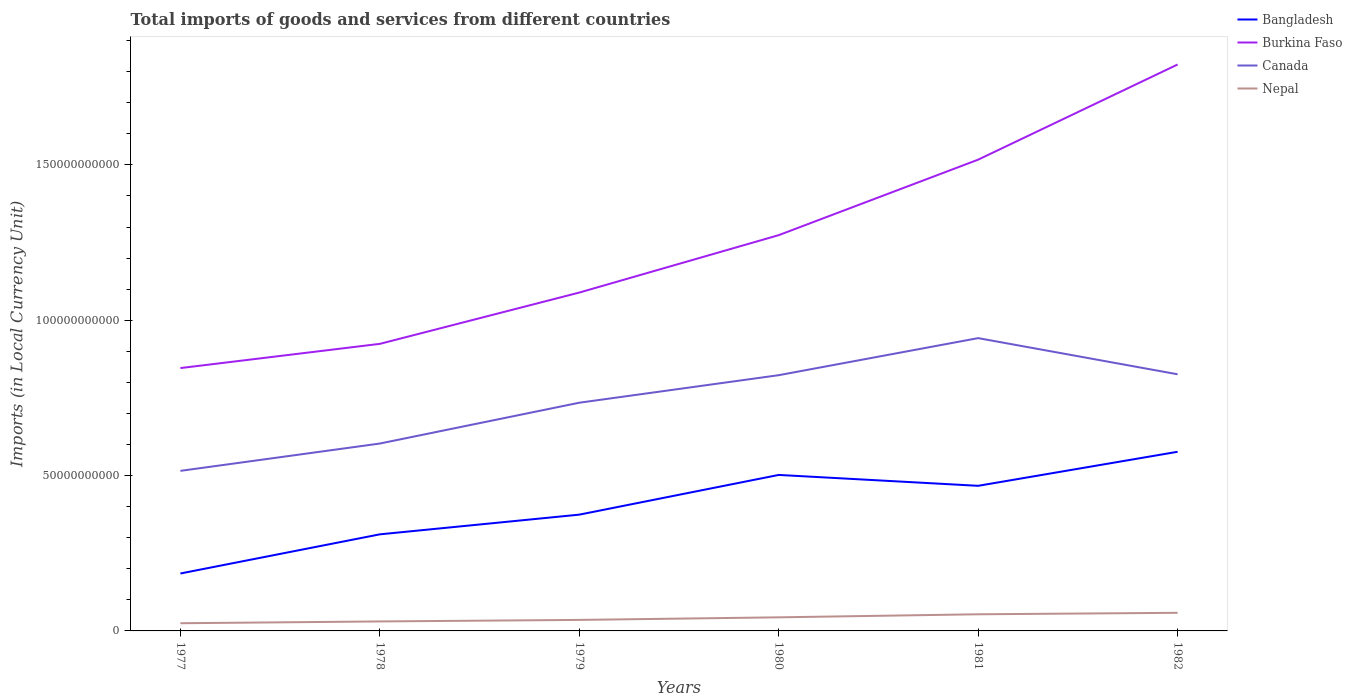How many different coloured lines are there?
Offer a very short reply. 4. Does the line corresponding to Burkina Faso intersect with the line corresponding to Bangladesh?
Provide a short and direct response. No. Is the number of lines equal to the number of legend labels?
Your response must be concise. Yes. Across all years, what is the maximum Amount of goods and services imports in Burkina Faso?
Provide a short and direct response. 8.46e+1. What is the total Amount of goods and services imports in Bangladesh in the graph?
Give a very brief answer. -1.10e+1. What is the difference between the highest and the second highest Amount of goods and services imports in Nepal?
Provide a short and direct response. 3.35e+09. What is the difference between the highest and the lowest Amount of goods and services imports in Burkina Faso?
Your answer should be compact. 3. Is the Amount of goods and services imports in Canada strictly greater than the Amount of goods and services imports in Bangladesh over the years?
Give a very brief answer. No. How many lines are there?
Give a very brief answer. 4. How many years are there in the graph?
Provide a succinct answer. 6. Are the values on the major ticks of Y-axis written in scientific E-notation?
Provide a succinct answer. No. Does the graph contain any zero values?
Your answer should be compact. No. Where does the legend appear in the graph?
Make the answer very short. Top right. How many legend labels are there?
Your answer should be compact. 4. What is the title of the graph?
Offer a very short reply. Total imports of goods and services from different countries. What is the label or title of the X-axis?
Provide a short and direct response. Years. What is the label or title of the Y-axis?
Provide a succinct answer. Imports (in Local Currency Unit). What is the Imports (in Local Currency Unit) of Bangladesh in 1977?
Offer a very short reply. 1.85e+1. What is the Imports (in Local Currency Unit) of Burkina Faso in 1977?
Give a very brief answer. 8.46e+1. What is the Imports (in Local Currency Unit) in Canada in 1977?
Your response must be concise. 5.15e+1. What is the Imports (in Local Currency Unit) of Nepal in 1977?
Your response must be concise. 2.47e+09. What is the Imports (in Local Currency Unit) in Bangladesh in 1978?
Keep it short and to the point. 3.11e+1. What is the Imports (in Local Currency Unit) of Burkina Faso in 1978?
Ensure brevity in your answer.  9.24e+1. What is the Imports (in Local Currency Unit) of Canada in 1978?
Provide a succinct answer. 6.03e+1. What is the Imports (in Local Currency Unit) of Nepal in 1978?
Keep it short and to the point. 3.05e+09. What is the Imports (in Local Currency Unit) of Bangladesh in 1979?
Your answer should be very brief. 3.74e+1. What is the Imports (in Local Currency Unit) of Burkina Faso in 1979?
Your answer should be very brief. 1.09e+11. What is the Imports (in Local Currency Unit) of Canada in 1979?
Provide a succinct answer. 7.35e+1. What is the Imports (in Local Currency Unit) of Nepal in 1979?
Your response must be concise. 3.55e+09. What is the Imports (in Local Currency Unit) in Bangladesh in 1980?
Give a very brief answer. 5.02e+1. What is the Imports (in Local Currency Unit) in Burkina Faso in 1980?
Offer a terse response. 1.27e+11. What is the Imports (in Local Currency Unit) of Canada in 1980?
Offer a very short reply. 8.23e+1. What is the Imports (in Local Currency Unit) of Nepal in 1980?
Your answer should be compact. 4.37e+09. What is the Imports (in Local Currency Unit) of Bangladesh in 1981?
Ensure brevity in your answer.  4.67e+1. What is the Imports (in Local Currency Unit) in Burkina Faso in 1981?
Make the answer very short. 1.52e+11. What is the Imports (in Local Currency Unit) in Canada in 1981?
Your answer should be compact. 9.42e+1. What is the Imports (in Local Currency Unit) in Nepal in 1981?
Keep it short and to the point. 5.36e+09. What is the Imports (in Local Currency Unit) of Bangladesh in 1982?
Make the answer very short. 5.77e+1. What is the Imports (in Local Currency Unit) of Burkina Faso in 1982?
Your response must be concise. 1.82e+11. What is the Imports (in Local Currency Unit) of Canada in 1982?
Make the answer very short. 8.26e+1. What is the Imports (in Local Currency Unit) in Nepal in 1982?
Make the answer very short. 5.83e+09. Across all years, what is the maximum Imports (in Local Currency Unit) of Bangladesh?
Offer a terse response. 5.77e+1. Across all years, what is the maximum Imports (in Local Currency Unit) in Burkina Faso?
Provide a succinct answer. 1.82e+11. Across all years, what is the maximum Imports (in Local Currency Unit) in Canada?
Offer a very short reply. 9.42e+1. Across all years, what is the maximum Imports (in Local Currency Unit) of Nepal?
Your answer should be very brief. 5.83e+09. Across all years, what is the minimum Imports (in Local Currency Unit) in Bangladesh?
Provide a short and direct response. 1.85e+1. Across all years, what is the minimum Imports (in Local Currency Unit) in Burkina Faso?
Ensure brevity in your answer.  8.46e+1. Across all years, what is the minimum Imports (in Local Currency Unit) in Canada?
Your answer should be compact. 5.15e+1. Across all years, what is the minimum Imports (in Local Currency Unit) of Nepal?
Provide a succinct answer. 2.47e+09. What is the total Imports (in Local Currency Unit) of Bangladesh in the graph?
Provide a succinct answer. 2.42e+11. What is the total Imports (in Local Currency Unit) in Burkina Faso in the graph?
Provide a succinct answer. 7.47e+11. What is the total Imports (in Local Currency Unit) in Canada in the graph?
Keep it short and to the point. 4.44e+11. What is the total Imports (in Local Currency Unit) in Nepal in the graph?
Your answer should be very brief. 2.46e+1. What is the difference between the Imports (in Local Currency Unit) in Bangladesh in 1977 and that in 1978?
Ensure brevity in your answer.  -1.26e+1. What is the difference between the Imports (in Local Currency Unit) in Burkina Faso in 1977 and that in 1978?
Offer a terse response. -7.80e+09. What is the difference between the Imports (in Local Currency Unit) of Canada in 1977 and that in 1978?
Your response must be concise. -8.80e+09. What is the difference between the Imports (in Local Currency Unit) in Nepal in 1977 and that in 1978?
Your answer should be compact. -5.79e+08. What is the difference between the Imports (in Local Currency Unit) of Bangladesh in 1977 and that in 1979?
Your response must be concise. -1.89e+1. What is the difference between the Imports (in Local Currency Unit) of Burkina Faso in 1977 and that in 1979?
Keep it short and to the point. -2.43e+1. What is the difference between the Imports (in Local Currency Unit) in Canada in 1977 and that in 1979?
Keep it short and to the point. -2.19e+1. What is the difference between the Imports (in Local Currency Unit) in Nepal in 1977 and that in 1979?
Ensure brevity in your answer.  -1.07e+09. What is the difference between the Imports (in Local Currency Unit) of Bangladesh in 1977 and that in 1980?
Make the answer very short. -3.17e+1. What is the difference between the Imports (in Local Currency Unit) of Burkina Faso in 1977 and that in 1980?
Ensure brevity in your answer.  -4.28e+1. What is the difference between the Imports (in Local Currency Unit) in Canada in 1977 and that in 1980?
Keep it short and to the point. -3.08e+1. What is the difference between the Imports (in Local Currency Unit) in Nepal in 1977 and that in 1980?
Ensure brevity in your answer.  -1.90e+09. What is the difference between the Imports (in Local Currency Unit) of Bangladesh in 1977 and that in 1981?
Your answer should be very brief. -2.82e+1. What is the difference between the Imports (in Local Currency Unit) in Burkina Faso in 1977 and that in 1981?
Offer a very short reply. -6.71e+1. What is the difference between the Imports (in Local Currency Unit) of Canada in 1977 and that in 1981?
Keep it short and to the point. -4.27e+1. What is the difference between the Imports (in Local Currency Unit) of Nepal in 1977 and that in 1981?
Ensure brevity in your answer.  -2.88e+09. What is the difference between the Imports (in Local Currency Unit) of Bangladesh in 1977 and that in 1982?
Offer a very short reply. -3.92e+1. What is the difference between the Imports (in Local Currency Unit) of Burkina Faso in 1977 and that in 1982?
Provide a short and direct response. -9.77e+1. What is the difference between the Imports (in Local Currency Unit) in Canada in 1977 and that in 1982?
Provide a short and direct response. -3.11e+1. What is the difference between the Imports (in Local Currency Unit) of Nepal in 1977 and that in 1982?
Give a very brief answer. -3.35e+09. What is the difference between the Imports (in Local Currency Unit) in Bangladesh in 1978 and that in 1979?
Your answer should be compact. -6.34e+09. What is the difference between the Imports (in Local Currency Unit) of Burkina Faso in 1978 and that in 1979?
Give a very brief answer. -1.65e+1. What is the difference between the Imports (in Local Currency Unit) in Canada in 1978 and that in 1979?
Your answer should be compact. -1.31e+1. What is the difference between the Imports (in Local Currency Unit) in Nepal in 1978 and that in 1979?
Make the answer very short. -4.94e+08. What is the difference between the Imports (in Local Currency Unit) in Bangladesh in 1978 and that in 1980?
Make the answer very short. -1.91e+1. What is the difference between the Imports (in Local Currency Unit) of Burkina Faso in 1978 and that in 1980?
Your response must be concise. -3.50e+1. What is the difference between the Imports (in Local Currency Unit) of Canada in 1978 and that in 1980?
Your answer should be compact. -2.20e+1. What is the difference between the Imports (in Local Currency Unit) in Nepal in 1978 and that in 1980?
Make the answer very short. -1.32e+09. What is the difference between the Imports (in Local Currency Unit) of Bangladesh in 1978 and that in 1981?
Provide a short and direct response. -1.56e+1. What is the difference between the Imports (in Local Currency Unit) in Burkina Faso in 1978 and that in 1981?
Provide a short and direct response. -5.93e+1. What is the difference between the Imports (in Local Currency Unit) of Canada in 1978 and that in 1981?
Your answer should be compact. -3.39e+1. What is the difference between the Imports (in Local Currency Unit) in Nepal in 1978 and that in 1981?
Keep it short and to the point. -2.30e+09. What is the difference between the Imports (in Local Currency Unit) in Bangladesh in 1978 and that in 1982?
Keep it short and to the point. -2.66e+1. What is the difference between the Imports (in Local Currency Unit) of Burkina Faso in 1978 and that in 1982?
Give a very brief answer. -8.99e+1. What is the difference between the Imports (in Local Currency Unit) of Canada in 1978 and that in 1982?
Give a very brief answer. -2.23e+1. What is the difference between the Imports (in Local Currency Unit) of Nepal in 1978 and that in 1982?
Make the answer very short. -2.77e+09. What is the difference between the Imports (in Local Currency Unit) of Bangladesh in 1979 and that in 1980?
Provide a short and direct response. -1.28e+1. What is the difference between the Imports (in Local Currency Unit) in Burkina Faso in 1979 and that in 1980?
Provide a succinct answer. -1.85e+1. What is the difference between the Imports (in Local Currency Unit) of Canada in 1979 and that in 1980?
Make the answer very short. -8.86e+09. What is the difference between the Imports (in Local Currency Unit) of Nepal in 1979 and that in 1980?
Give a very brief answer. -8.27e+08. What is the difference between the Imports (in Local Currency Unit) in Bangladesh in 1979 and that in 1981?
Your response must be concise. -9.28e+09. What is the difference between the Imports (in Local Currency Unit) in Burkina Faso in 1979 and that in 1981?
Keep it short and to the point. -4.28e+1. What is the difference between the Imports (in Local Currency Unit) in Canada in 1979 and that in 1981?
Your response must be concise. -2.08e+1. What is the difference between the Imports (in Local Currency Unit) of Nepal in 1979 and that in 1981?
Keep it short and to the point. -1.81e+09. What is the difference between the Imports (in Local Currency Unit) of Bangladesh in 1979 and that in 1982?
Make the answer very short. -2.02e+1. What is the difference between the Imports (in Local Currency Unit) in Burkina Faso in 1979 and that in 1982?
Offer a terse response. -7.34e+1. What is the difference between the Imports (in Local Currency Unit) in Canada in 1979 and that in 1982?
Your response must be concise. -9.15e+09. What is the difference between the Imports (in Local Currency Unit) in Nepal in 1979 and that in 1982?
Provide a short and direct response. -2.28e+09. What is the difference between the Imports (in Local Currency Unit) in Bangladesh in 1980 and that in 1981?
Ensure brevity in your answer.  3.50e+09. What is the difference between the Imports (in Local Currency Unit) in Burkina Faso in 1980 and that in 1981?
Ensure brevity in your answer.  -2.43e+1. What is the difference between the Imports (in Local Currency Unit) in Canada in 1980 and that in 1981?
Give a very brief answer. -1.19e+1. What is the difference between the Imports (in Local Currency Unit) of Nepal in 1980 and that in 1981?
Make the answer very short. -9.83e+08. What is the difference between the Imports (in Local Currency Unit) in Bangladesh in 1980 and that in 1982?
Make the answer very short. -7.45e+09. What is the difference between the Imports (in Local Currency Unit) in Burkina Faso in 1980 and that in 1982?
Ensure brevity in your answer.  -5.49e+1. What is the difference between the Imports (in Local Currency Unit) in Canada in 1980 and that in 1982?
Your response must be concise. -2.93e+08. What is the difference between the Imports (in Local Currency Unit) in Nepal in 1980 and that in 1982?
Your response must be concise. -1.45e+09. What is the difference between the Imports (in Local Currency Unit) of Bangladesh in 1981 and that in 1982?
Provide a short and direct response. -1.10e+1. What is the difference between the Imports (in Local Currency Unit) in Burkina Faso in 1981 and that in 1982?
Keep it short and to the point. -3.06e+1. What is the difference between the Imports (in Local Currency Unit) of Canada in 1981 and that in 1982?
Your response must be concise. 1.16e+1. What is the difference between the Imports (in Local Currency Unit) in Nepal in 1981 and that in 1982?
Ensure brevity in your answer.  -4.71e+08. What is the difference between the Imports (in Local Currency Unit) in Bangladesh in 1977 and the Imports (in Local Currency Unit) in Burkina Faso in 1978?
Give a very brief answer. -7.39e+1. What is the difference between the Imports (in Local Currency Unit) of Bangladesh in 1977 and the Imports (in Local Currency Unit) of Canada in 1978?
Offer a terse response. -4.18e+1. What is the difference between the Imports (in Local Currency Unit) in Bangladesh in 1977 and the Imports (in Local Currency Unit) in Nepal in 1978?
Offer a very short reply. 1.54e+1. What is the difference between the Imports (in Local Currency Unit) of Burkina Faso in 1977 and the Imports (in Local Currency Unit) of Canada in 1978?
Keep it short and to the point. 2.43e+1. What is the difference between the Imports (in Local Currency Unit) in Burkina Faso in 1977 and the Imports (in Local Currency Unit) in Nepal in 1978?
Your answer should be very brief. 8.16e+1. What is the difference between the Imports (in Local Currency Unit) of Canada in 1977 and the Imports (in Local Currency Unit) of Nepal in 1978?
Your response must be concise. 4.85e+1. What is the difference between the Imports (in Local Currency Unit) in Bangladesh in 1977 and the Imports (in Local Currency Unit) in Burkina Faso in 1979?
Provide a short and direct response. -9.04e+1. What is the difference between the Imports (in Local Currency Unit) in Bangladesh in 1977 and the Imports (in Local Currency Unit) in Canada in 1979?
Your answer should be compact. -5.50e+1. What is the difference between the Imports (in Local Currency Unit) of Bangladesh in 1977 and the Imports (in Local Currency Unit) of Nepal in 1979?
Ensure brevity in your answer.  1.49e+1. What is the difference between the Imports (in Local Currency Unit) in Burkina Faso in 1977 and the Imports (in Local Currency Unit) in Canada in 1979?
Provide a succinct answer. 1.12e+1. What is the difference between the Imports (in Local Currency Unit) in Burkina Faso in 1977 and the Imports (in Local Currency Unit) in Nepal in 1979?
Provide a succinct answer. 8.11e+1. What is the difference between the Imports (in Local Currency Unit) of Canada in 1977 and the Imports (in Local Currency Unit) of Nepal in 1979?
Offer a very short reply. 4.80e+1. What is the difference between the Imports (in Local Currency Unit) in Bangladesh in 1977 and the Imports (in Local Currency Unit) in Burkina Faso in 1980?
Provide a succinct answer. -1.09e+11. What is the difference between the Imports (in Local Currency Unit) in Bangladesh in 1977 and the Imports (in Local Currency Unit) in Canada in 1980?
Provide a succinct answer. -6.38e+1. What is the difference between the Imports (in Local Currency Unit) in Bangladesh in 1977 and the Imports (in Local Currency Unit) in Nepal in 1980?
Keep it short and to the point. 1.41e+1. What is the difference between the Imports (in Local Currency Unit) in Burkina Faso in 1977 and the Imports (in Local Currency Unit) in Canada in 1980?
Offer a terse response. 2.29e+09. What is the difference between the Imports (in Local Currency Unit) of Burkina Faso in 1977 and the Imports (in Local Currency Unit) of Nepal in 1980?
Your response must be concise. 8.02e+1. What is the difference between the Imports (in Local Currency Unit) of Canada in 1977 and the Imports (in Local Currency Unit) of Nepal in 1980?
Give a very brief answer. 4.71e+1. What is the difference between the Imports (in Local Currency Unit) of Bangladesh in 1977 and the Imports (in Local Currency Unit) of Burkina Faso in 1981?
Provide a succinct answer. -1.33e+11. What is the difference between the Imports (in Local Currency Unit) in Bangladesh in 1977 and the Imports (in Local Currency Unit) in Canada in 1981?
Provide a succinct answer. -7.58e+1. What is the difference between the Imports (in Local Currency Unit) of Bangladesh in 1977 and the Imports (in Local Currency Unit) of Nepal in 1981?
Keep it short and to the point. 1.31e+1. What is the difference between the Imports (in Local Currency Unit) of Burkina Faso in 1977 and the Imports (in Local Currency Unit) of Canada in 1981?
Give a very brief answer. -9.64e+09. What is the difference between the Imports (in Local Currency Unit) of Burkina Faso in 1977 and the Imports (in Local Currency Unit) of Nepal in 1981?
Offer a very short reply. 7.93e+1. What is the difference between the Imports (in Local Currency Unit) of Canada in 1977 and the Imports (in Local Currency Unit) of Nepal in 1981?
Your answer should be compact. 4.62e+1. What is the difference between the Imports (in Local Currency Unit) of Bangladesh in 1977 and the Imports (in Local Currency Unit) of Burkina Faso in 1982?
Offer a terse response. -1.64e+11. What is the difference between the Imports (in Local Currency Unit) in Bangladesh in 1977 and the Imports (in Local Currency Unit) in Canada in 1982?
Your response must be concise. -6.41e+1. What is the difference between the Imports (in Local Currency Unit) of Bangladesh in 1977 and the Imports (in Local Currency Unit) of Nepal in 1982?
Provide a short and direct response. 1.27e+1. What is the difference between the Imports (in Local Currency Unit) in Burkina Faso in 1977 and the Imports (in Local Currency Unit) in Canada in 1982?
Keep it short and to the point. 2.00e+09. What is the difference between the Imports (in Local Currency Unit) in Burkina Faso in 1977 and the Imports (in Local Currency Unit) in Nepal in 1982?
Offer a terse response. 7.88e+1. What is the difference between the Imports (in Local Currency Unit) of Canada in 1977 and the Imports (in Local Currency Unit) of Nepal in 1982?
Make the answer very short. 4.57e+1. What is the difference between the Imports (in Local Currency Unit) in Bangladesh in 1978 and the Imports (in Local Currency Unit) in Burkina Faso in 1979?
Ensure brevity in your answer.  -7.78e+1. What is the difference between the Imports (in Local Currency Unit) in Bangladesh in 1978 and the Imports (in Local Currency Unit) in Canada in 1979?
Provide a short and direct response. -4.24e+1. What is the difference between the Imports (in Local Currency Unit) of Bangladesh in 1978 and the Imports (in Local Currency Unit) of Nepal in 1979?
Provide a succinct answer. 2.75e+1. What is the difference between the Imports (in Local Currency Unit) in Burkina Faso in 1978 and the Imports (in Local Currency Unit) in Canada in 1979?
Your response must be concise. 1.89e+1. What is the difference between the Imports (in Local Currency Unit) of Burkina Faso in 1978 and the Imports (in Local Currency Unit) of Nepal in 1979?
Your answer should be very brief. 8.89e+1. What is the difference between the Imports (in Local Currency Unit) of Canada in 1978 and the Imports (in Local Currency Unit) of Nepal in 1979?
Ensure brevity in your answer.  5.68e+1. What is the difference between the Imports (in Local Currency Unit) in Bangladesh in 1978 and the Imports (in Local Currency Unit) in Burkina Faso in 1980?
Your answer should be very brief. -9.63e+1. What is the difference between the Imports (in Local Currency Unit) of Bangladesh in 1978 and the Imports (in Local Currency Unit) of Canada in 1980?
Make the answer very short. -5.12e+1. What is the difference between the Imports (in Local Currency Unit) of Bangladesh in 1978 and the Imports (in Local Currency Unit) of Nepal in 1980?
Your answer should be very brief. 2.67e+1. What is the difference between the Imports (in Local Currency Unit) of Burkina Faso in 1978 and the Imports (in Local Currency Unit) of Canada in 1980?
Ensure brevity in your answer.  1.01e+1. What is the difference between the Imports (in Local Currency Unit) in Burkina Faso in 1978 and the Imports (in Local Currency Unit) in Nepal in 1980?
Offer a very short reply. 8.80e+1. What is the difference between the Imports (in Local Currency Unit) in Canada in 1978 and the Imports (in Local Currency Unit) in Nepal in 1980?
Your answer should be very brief. 5.59e+1. What is the difference between the Imports (in Local Currency Unit) in Bangladesh in 1978 and the Imports (in Local Currency Unit) in Burkina Faso in 1981?
Provide a succinct answer. -1.21e+11. What is the difference between the Imports (in Local Currency Unit) in Bangladesh in 1978 and the Imports (in Local Currency Unit) in Canada in 1981?
Ensure brevity in your answer.  -6.32e+1. What is the difference between the Imports (in Local Currency Unit) in Bangladesh in 1978 and the Imports (in Local Currency Unit) in Nepal in 1981?
Your answer should be very brief. 2.57e+1. What is the difference between the Imports (in Local Currency Unit) in Burkina Faso in 1978 and the Imports (in Local Currency Unit) in Canada in 1981?
Offer a very short reply. -1.84e+09. What is the difference between the Imports (in Local Currency Unit) in Burkina Faso in 1978 and the Imports (in Local Currency Unit) in Nepal in 1981?
Provide a succinct answer. 8.70e+1. What is the difference between the Imports (in Local Currency Unit) of Canada in 1978 and the Imports (in Local Currency Unit) of Nepal in 1981?
Give a very brief answer. 5.50e+1. What is the difference between the Imports (in Local Currency Unit) of Bangladesh in 1978 and the Imports (in Local Currency Unit) of Burkina Faso in 1982?
Give a very brief answer. -1.51e+11. What is the difference between the Imports (in Local Currency Unit) in Bangladesh in 1978 and the Imports (in Local Currency Unit) in Canada in 1982?
Keep it short and to the point. -5.15e+1. What is the difference between the Imports (in Local Currency Unit) in Bangladesh in 1978 and the Imports (in Local Currency Unit) in Nepal in 1982?
Provide a short and direct response. 2.53e+1. What is the difference between the Imports (in Local Currency Unit) in Burkina Faso in 1978 and the Imports (in Local Currency Unit) in Canada in 1982?
Give a very brief answer. 9.79e+09. What is the difference between the Imports (in Local Currency Unit) in Burkina Faso in 1978 and the Imports (in Local Currency Unit) in Nepal in 1982?
Your response must be concise. 8.66e+1. What is the difference between the Imports (in Local Currency Unit) in Canada in 1978 and the Imports (in Local Currency Unit) in Nepal in 1982?
Ensure brevity in your answer.  5.45e+1. What is the difference between the Imports (in Local Currency Unit) of Bangladesh in 1979 and the Imports (in Local Currency Unit) of Burkina Faso in 1980?
Ensure brevity in your answer.  -9.00e+1. What is the difference between the Imports (in Local Currency Unit) in Bangladesh in 1979 and the Imports (in Local Currency Unit) in Canada in 1980?
Your response must be concise. -4.49e+1. What is the difference between the Imports (in Local Currency Unit) in Bangladesh in 1979 and the Imports (in Local Currency Unit) in Nepal in 1980?
Make the answer very short. 3.31e+1. What is the difference between the Imports (in Local Currency Unit) in Burkina Faso in 1979 and the Imports (in Local Currency Unit) in Canada in 1980?
Offer a very short reply. 2.66e+1. What is the difference between the Imports (in Local Currency Unit) of Burkina Faso in 1979 and the Imports (in Local Currency Unit) of Nepal in 1980?
Provide a short and direct response. 1.05e+11. What is the difference between the Imports (in Local Currency Unit) in Canada in 1979 and the Imports (in Local Currency Unit) in Nepal in 1980?
Ensure brevity in your answer.  6.91e+1. What is the difference between the Imports (in Local Currency Unit) in Bangladesh in 1979 and the Imports (in Local Currency Unit) in Burkina Faso in 1981?
Make the answer very short. -1.14e+11. What is the difference between the Imports (in Local Currency Unit) in Bangladesh in 1979 and the Imports (in Local Currency Unit) in Canada in 1981?
Your answer should be compact. -5.68e+1. What is the difference between the Imports (in Local Currency Unit) of Bangladesh in 1979 and the Imports (in Local Currency Unit) of Nepal in 1981?
Give a very brief answer. 3.21e+1. What is the difference between the Imports (in Local Currency Unit) in Burkina Faso in 1979 and the Imports (in Local Currency Unit) in Canada in 1981?
Provide a short and direct response. 1.47e+1. What is the difference between the Imports (in Local Currency Unit) in Burkina Faso in 1979 and the Imports (in Local Currency Unit) in Nepal in 1981?
Make the answer very short. 1.04e+11. What is the difference between the Imports (in Local Currency Unit) in Canada in 1979 and the Imports (in Local Currency Unit) in Nepal in 1981?
Your answer should be very brief. 6.81e+1. What is the difference between the Imports (in Local Currency Unit) of Bangladesh in 1979 and the Imports (in Local Currency Unit) of Burkina Faso in 1982?
Your answer should be compact. -1.45e+11. What is the difference between the Imports (in Local Currency Unit) in Bangladesh in 1979 and the Imports (in Local Currency Unit) in Canada in 1982?
Your answer should be very brief. -4.52e+1. What is the difference between the Imports (in Local Currency Unit) in Bangladesh in 1979 and the Imports (in Local Currency Unit) in Nepal in 1982?
Keep it short and to the point. 3.16e+1. What is the difference between the Imports (in Local Currency Unit) of Burkina Faso in 1979 and the Imports (in Local Currency Unit) of Canada in 1982?
Ensure brevity in your answer.  2.63e+1. What is the difference between the Imports (in Local Currency Unit) of Burkina Faso in 1979 and the Imports (in Local Currency Unit) of Nepal in 1982?
Offer a terse response. 1.03e+11. What is the difference between the Imports (in Local Currency Unit) of Canada in 1979 and the Imports (in Local Currency Unit) of Nepal in 1982?
Offer a very short reply. 6.76e+1. What is the difference between the Imports (in Local Currency Unit) of Bangladesh in 1980 and the Imports (in Local Currency Unit) of Burkina Faso in 1981?
Give a very brief answer. -1.01e+11. What is the difference between the Imports (in Local Currency Unit) of Bangladesh in 1980 and the Imports (in Local Currency Unit) of Canada in 1981?
Your answer should be compact. -4.40e+1. What is the difference between the Imports (in Local Currency Unit) of Bangladesh in 1980 and the Imports (in Local Currency Unit) of Nepal in 1981?
Your answer should be compact. 4.49e+1. What is the difference between the Imports (in Local Currency Unit) in Burkina Faso in 1980 and the Imports (in Local Currency Unit) in Canada in 1981?
Your response must be concise. 3.31e+1. What is the difference between the Imports (in Local Currency Unit) of Burkina Faso in 1980 and the Imports (in Local Currency Unit) of Nepal in 1981?
Make the answer very short. 1.22e+11. What is the difference between the Imports (in Local Currency Unit) in Canada in 1980 and the Imports (in Local Currency Unit) in Nepal in 1981?
Your response must be concise. 7.70e+1. What is the difference between the Imports (in Local Currency Unit) in Bangladesh in 1980 and the Imports (in Local Currency Unit) in Burkina Faso in 1982?
Offer a terse response. -1.32e+11. What is the difference between the Imports (in Local Currency Unit) of Bangladesh in 1980 and the Imports (in Local Currency Unit) of Canada in 1982?
Your answer should be compact. -3.24e+1. What is the difference between the Imports (in Local Currency Unit) in Bangladesh in 1980 and the Imports (in Local Currency Unit) in Nepal in 1982?
Your answer should be very brief. 4.44e+1. What is the difference between the Imports (in Local Currency Unit) of Burkina Faso in 1980 and the Imports (in Local Currency Unit) of Canada in 1982?
Your answer should be compact. 4.48e+1. What is the difference between the Imports (in Local Currency Unit) of Burkina Faso in 1980 and the Imports (in Local Currency Unit) of Nepal in 1982?
Your response must be concise. 1.22e+11. What is the difference between the Imports (in Local Currency Unit) in Canada in 1980 and the Imports (in Local Currency Unit) in Nepal in 1982?
Keep it short and to the point. 7.65e+1. What is the difference between the Imports (in Local Currency Unit) in Bangladesh in 1981 and the Imports (in Local Currency Unit) in Burkina Faso in 1982?
Make the answer very short. -1.36e+11. What is the difference between the Imports (in Local Currency Unit) of Bangladesh in 1981 and the Imports (in Local Currency Unit) of Canada in 1982?
Your response must be concise. -3.59e+1. What is the difference between the Imports (in Local Currency Unit) of Bangladesh in 1981 and the Imports (in Local Currency Unit) of Nepal in 1982?
Your answer should be compact. 4.09e+1. What is the difference between the Imports (in Local Currency Unit) in Burkina Faso in 1981 and the Imports (in Local Currency Unit) in Canada in 1982?
Make the answer very short. 6.91e+1. What is the difference between the Imports (in Local Currency Unit) in Burkina Faso in 1981 and the Imports (in Local Currency Unit) in Nepal in 1982?
Provide a short and direct response. 1.46e+11. What is the difference between the Imports (in Local Currency Unit) of Canada in 1981 and the Imports (in Local Currency Unit) of Nepal in 1982?
Offer a terse response. 8.84e+1. What is the average Imports (in Local Currency Unit) in Bangladesh per year?
Your answer should be compact. 4.03e+1. What is the average Imports (in Local Currency Unit) in Burkina Faso per year?
Offer a very short reply. 1.25e+11. What is the average Imports (in Local Currency Unit) in Canada per year?
Ensure brevity in your answer.  7.41e+1. What is the average Imports (in Local Currency Unit) in Nepal per year?
Ensure brevity in your answer.  4.11e+09. In the year 1977, what is the difference between the Imports (in Local Currency Unit) in Bangladesh and Imports (in Local Currency Unit) in Burkina Faso?
Provide a succinct answer. -6.61e+1. In the year 1977, what is the difference between the Imports (in Local Currency Unit) in Bangladesh and Imports (in Local Currency Unit) in Canada?
Offer a very short reply. -3.30e+1. In the year 1977, what is the difference between the Imports (in Local Currency Unit) of Bangladesh and Imports (in Local Currency Unit) of Nepal?
Your response must be concise. 1.60e+1. In the year 1977, what is the difference between the Imports (in Local Currency Unit) of Burkina Faso and Imports (in Local Currency Unit) of Canada?
Your answer should be very brief. 3.31e+1. In the year 1977, what is the difference between the Imports (in Local Currency Unit) in Burkina Faso and Imports (in Local Currency Unit) in Nepal?
Give a very brief answer. 8.21e+1. In the year 1977, what is the difference between the Imports (in Local Currency Unit) in Canada and Imports (in Local Currency Unit) in Nepal?
Provide a short and direct response. 4.90e+1. In the year 1978, what is the difference between the Imports (in Local Currency Unit) of Bangladesh and Imports (in Local Currency Unit) of Burkina Faso?
Offer a very short reply. -6.13e+1. In the year 1978, what is the difference between the Imports (in Local Currency Unit) of Bangladesh and Imports (in Local Currency Unit) of Canada?
Offer a very short reply. -2.92e+1. In the year 1978, what is the difference between the Imports (in Local Currency Unit) in Bangladesh and Imports (in Local Currency Unit) in Nepal?
Provide a succinct answer. 2.80e+1. In the year 1978, what is the difference between the Imports (in Local Currency Unit) in Burkina Faso and Imports (in Local Currency Unit) in Canada?
Offer a very short reply. 3.21e+1. In the year 1978, what is the difference between the Imports (in Local Currency Unit) of Burkina Faso and Imports (in Local Currency Unit) of Nepal?
Your answer should be compact. 8.94e+1. In the year 1978, what is the difference between the Imports (in Local Currency Unit) in Canada and Imports (in Local Currency Unit) in Nepal?
Make the answer very short. 5.73e+1. In the year 1979, what is the difference between the Imports (in Local Currency Unit) of Bangladesh and Imports (in Local Currency Unit) of Burkina Faso?
Offer a terse response. -7.15e+1. In the year 1979, what is the difference between the Imports (in Local Currency Unit) of Bangladesh and Imports (in Local Currency Unit) of Canada?
Ensure brevity in your answer.  -3.60e+1. In the year 1979, what is the difference between the Imports (in Local Currency Unit) in Bangladesh and Imports (in Local Currency Unit) in Nepal?
Provide a short and direct response. 3.39e+1. In the year 1979, what is the difference between the Imports (in Local Currency Unit) of Burkina Faso and Imports (in Local Currency Unit) of Canada?
Give a very brief answer. 3.55e+1. In the year 1979, what is the difference between the Imports (in Local Currency Unit) in Burkina Faso and Imports (in Local Currency Unit) in Nepal?
Give a very brief answer. 1.05e+11. In the year 1979, what is the difference between the Imports (in Local Currency Unit) in Canada and Imports (in Local Currency Unit) in Nepal?
Your answer should be compact. 6.99e+1. In the year 1980, what is the difference between the Imports (in Local Currency Unit) of Bangladesh and Imports (in Local Currency Unit) of Burkina Faso?
Your answer should be very brief. -7.72e+1. In the year 1980, what is the difference between the Imports (in Local Currency Unit) in Bangladesh and Imports (in Local Currency Unit) in Canada?
Offer a terse response. -3.21e+1. In the year 1980, what is the difference between the Imports (in Local Currency Unit) of Bangladesh and Imports (in Local Currency Unit) of Nepal?
Offer a terse response. 4.58e+1. In the year 1980, what is the difference between the Imports (in Local Currency Unit) in Burkina Faso and Imports (in Local Currency Unit) in Canada?
Ensure brevity in your answer.  4.51e+1. In the year 1980, what is the difference between the Imports (in Local Currency Unit) of Burkina Faso and Imports (in Local Currency Unit) of Nepal?
Your response must be concise. 1.23e+11. In the year 1980, what is the difference between the Imports (in Local Currency Unit) of Canada and Imports (in Local Currency Unit) of Nepal?
Your answer should be compact. 7.79e+1. In the year 1981, what is the difference between the Imports (in Local Currency Unit) in Bangladesh and Imports (in Local Currency Unit) in Burkina Faso?
Your answer should be very brief. -1.05e+11. In the year 1981, what is the difference between the Imports (in Local Currency Unit) in Bangladesh and Imports (in Local Currency Unit) in Canada?
Make the answer very short. -4.75e+1. In the year 1981, what is the difference between the Imports (in Local Currency Unit) of Bangladesh and Imports (in Local Currency Unit) of Nepal?
Ensure brevity in your answer.  4.14e+1. In the year 1981, what is the difference between the Imports (in Local Currency Unit) in Burkina Faso and Imports (in Local Currency Unit) in Canada?
Make the answer very short. 5.74e+1. In the year 1981, what is the difference between the Imports (in Local Currency Unit) in Burkina Faso and Imports (in Local Currency Unit) in Nepal?
Give a very brief answer. 1.46e+11. In the year 1981, what is the difference between the Imports (in Local Currency Unit) of Canada and Imports (in Local Currency Unit) of Nepal?
Provide a short and direct response. 8.89e+1. In the year 1982, what is the difference between the Imports (in Local Currency Unit) in Bangladesh and Imports (in Local Currency Unit) in Burkina Faso?
Give a very brief answer. -1.25e+11. In the year 1982, what is the difference between the Imports (in Local Currency Unit) of Bangladesh and Imports (in Local Currency Unit) of Canada?
Offer a terse response. -2.49e+1. In the year 1982, what is the difference between the Imports (in Local Currency Unit) of Bangladesh and Imports (in Local Currency Unit) of Nepal?
Offer a very short reply. 5.18e+1. In the year 1982, what is the difference between the Imports (in Local Currency Unit) in Burkina Faso and Imports (in Local Currency Unit) in Canada?
Provide a succinct answer. 9.97e+1. In the year 1982, what is the difference between the Imports (in Local Currency Unit) in Burkina Faso and Imports (in Local Currency Unit) in Nepal?
Your response must be concise. 1.76e+11. In the year 1982, what is the difference between the Imports (in Local Currency Unit) in Canada and Imports (in Local Currency Unit) in Nepal?
Offer a terse response. 7.68e+1. What is the ratio of the Imports (in Local Currency Unit) of Bangladesh in 1977 to that in 1978?
Make the answer very short. 0.59. What is the ratio of the Imports (in Local Currency Unit) in Burkina Faso in 1977 to that in 1978?
Your response must be concise. 0.92. What is the ratio of the Imports (in Local Currency Unit) in Canada in 1977 to that in 1978?
Offer a terse response. 0.85. What is the ratio of the Imports (in Local Currency Unit) of Nepal in 1977 to that in 1978?
Your response must be concise. 0.81. What is the ratio of the Imports (in Local Currency Unit) of Bangladesh in 1977 to that in 1979?
Ensure brevity in your answer.  0.49. What is the ratio of the Imports (in Local Currency Unit) of Burkina Faso in 1977 to that in 1979?
Give a very brief answer. 0.78. What is the ratio of the Imports (in Local Currency Unit) in Canada in 1977 to that in 1979?
Your answer should be very brief. 0.7. What is the ratio of the Imports (in Local Currency Unit) in Nepal in 1977 to that in 1979?
Keep it short and to the point. 0.7. What is the ratio of the Imports (in Local Currency Unit) of Bangladesh in 1977 to that in 1980?
Your response must be concise. 0.37. What is the ratio of the Imports (in Local Currency Unit) of Burkina Faso in 1977 to that in 1980?
Ensure brevity in your answer.  0.66. What is the ratio of the Imports (in Local Currency Unit) in Canada in 1977 to that in 1980?
Your answer should be very brief. 0.63. What is the ratio of the Imports (in Local Currency Unit) in Nepal in 1977 to that in 1980?
Offer a very short reply. 0.57. What is the ratio of the Imports (in Local Currency Unit) of Bangladesh in 1977 to that in 1981?
Keep it short and to the point. 0.4. What is the ratio of the Imports (in Local Currency Unit) of Burkina Faso in 1977 to that in 1981?
Your answer should be compact. 0.56. What is the ratio of the Imports (in Local Currency Unit) in Canada in 1977 to that in 1981?
Provide a succinct answer. 0.55. What is the ratio of the Imports (in Local Currency Unit) of Nepal in 1977 to that in 1981?
Your response must be concise. 0.46. What is the ratio of the Imports (in Local Currency Unit) of Bangladesh in 1977 to that in 1982?
Provide a short and direct response. 0.32. What is the ratio of the Imports (in Local Currency Unit) of Burkina Faso in 1977 to that in 1982?
Offer a terse response. 0.46. What is the ratio of the Imports (in Local Currency Unit) in Canada in 1977 to that in 1982?
Keep it short and to the point. 0.62. What is the ratio of the Imports (in Local Currency Unit) of Nepal in 1977 to that in 1982?
Your answer should be very brief. 0.42. What is the ratio of the Imports (in Local Currency Unit) of Bangladesh in 1978 to that in 1979?
Your answer should be very brief. 0.83. What is the ratio of the Imports (in Local Currency Unit) in Burkina Faso in 1978 to that in 1979?
Offer a terse response. 0.85. What is the ratio of the Imports (in Local Currency Unit) of Canada in 1978 to that in 1979?
Give a very brief answer. 0.82. What is the ratio of the Imports (in Local Currency Unit) in Nepal in 1978 to that in 1979?
Provide a short and direct response. 0.86. What is the ratio of the Imports (in Local Currency Unit) of Bangladesh in 1978 to that in 1980?
Your response must be concise. 0.62. What is the ratio of the Imports (in Local Currency Unit) in Burkina Faso in 1978 to that in 1980?
Make the answer very short. 0.73. What is the ratio of the Imports (in Local Currency Unit) in Canada in 1978 to that in 1980?
Make the answer very short. 0.73. What is the ratio of the Imports (in Local Currency Unit) of Nepal in 1978 to that in 1980?
Give a very brief answer. 0.7. What is the ratio of the Imports (in Local Currency Unit) in Bangladesh in 1978 to that in 1981?
Offer a very short reply. 0.67. What is the ratio of the Imports (in Local Currency Unit) of Burkina Faso in 1978 to that in 1981?
Keep it short and to the point. 0.61. What is the ratio of the Imports (in Local Currency Unit) of Canada in 1978 to that in 1981?
Your answer should be compact. 0.64. What is the ratio of the Imports (in Local Currency Unit) of Nepal in 1978 to that in 1981?
Offer a very short reply. 0.57. What is the ratio of the Imports (in Local Currency Unit) of Bangladesh in 1978 to that in 1982?
Keep it short and to the point. 0.54. What is the ratio of the Imports (in Local Currency Unit) of Burkina Faso in 1978 to that in 1982?
Make the answer very short. 0.51. What is the ratio of the Imports (in Local Currency Unit) in Canada in 1978 to that in 1982?
Ensure brevity in your answer.  0.73. What is the ratio of the Imports (in Local Currency Unit) of Nepal in 1978 to that in 1982?
Offer a terse response. 0.52. What is the ratio of the Imports (in Local Currency Unit) of Bangladesh in 1979 to that in 1980?
Offer a terse response. 0.75. What is the ratio of the Imports (in Local Currency Unit) of Burkina Faso in 1979 to that in 1980?
Offer a terse response. 0.85. What is the ratio of the Imports (in Local Currency Unit) in Canada in 1979 to that in 1980?
Your answer should be compact. 0.89. What is the ratio of the Imports (in Local Currency Unit) in Nepal in 1979 to that in 1980?
Ensure brevity in your answer.  0.81. What is the ratio of the Imports (in Local Currency Unit) of Bangladesh in 1979 to that in 1981?
Your answer should be compact. 0.8. What is the ratio of the Imports (in Local Currency Unit) of Burkina Faso in 1979 to that in 1981?
Make the answer very short. 0.72. What is the ratio of the Imports (in Local Currency Unit) in Canada in 1979 to that in 1981?
Your answer should be very brief. 0.78. What is the ratio of the Imports (in Local Currency Unit) in Nepal in 1979 to that in 1981?
Make the answer very short. 0.66. What is the ratio of the Imports (in Local Currency Unit) of Bangladesh in 1979 to that in 1982?
Give a very brief answer. 0.65. What is the ratio of the Imports (in Local Currency Unit) of Burkina Faso in 1979 to that in 1982?
Offer a very short reply. 0.6. What is the ratio of the Imports (in Local Currency Unit) of Canada in 1979 to that in 1982?
Provide a short and direct response. 0.89. What is the ratio of the Imports (in Local Currency Unit) of Nepal in 1979 to that in 1982?
Provide a short and direct response. 0.61. What is the ratio of the Imports (in Local Currency Unit) of Bangladesh in 1980 to that in 1981?
Give a very brief answer. 1.07. What is the ratio of the Imports (in Local Currency Unit) of Burkina Faso in 1980 to that in 1981?
Keep it short and to the point. 0.84. What is the ratio of the Imports (in Local Currency Unit) of Canada in 1980 to that in 1981?
Provide a succinct answer. 0.87. What is the ratio of the Imports (in Local Currency Unit) of Nepal in 1980 to that in 1981?
Keep it short and to the point. 0.82. What is the ratio of the Imports (in Local Currency Unit) in Bangladesh in 1980 to that in 1982?
Provide a short and direct response. 0.87. What is the ratio of the Imports (in Local Currency Unit) in Burkina Faso in 1980 to that in 1982?
Ensure brevity in your answer.  0.7. What is the ratio of the Imports (in Local Currency Unit) in Nepal in 1980 to that in 1982?
Offer a very short reply. 0.75. What is the ratio of the Imports (in Local Currency Unit) in Bangladesh in 1981 to that in 1982?
Ensure brevity in your answer.  0.81. What is the ratio of the Imports (in Local Currency Unit) in Burkina Faso in 1981 to that in 1982?
Give a very brief answer. 0.83. What is the ratio of the Imports (in Local Currency Unit) in Canada in 1981 to that in 1982?
Give a very brief answer. 1.14. What is the ratio of the Imports (in Local Currency Unit) in Nepal in 1981 to that in 1982?
Your response must be concise. 0.92. What is the difference between the highest and the second highest Imports (in Local Currency Unit) of Bangladesh?
Your response must be concise. 7.45e+09. What is the difference between the highest and the second highest Imports (in Local Currency Unit) in Burkina Faso?
Give a very brief answer. 3.06e+1. What is the difference between the highest and the second highest Imports (in Local Currency Unit) in Canada?
Ensure brevity in your answer.  1.16e+1. What is the difference between the highest and the second highest Imports (in Local Currency Unit) in Nepal?
Make the answer very short. 4.71e+08. What is the difference between the highest and the lowest Imports (in Local Currency Unit) of Bangladesh?
Your response must be concise. 3.92e+1. What is the difference between the highest and the lowest Imports (in Local Currency Unit) of Burkina Faso?
Give a very brief answer. 9.77e+1. What is the difference between the highest and the lowest Imports (in Local Currency Unit) of Canada?
Your answer should be very brief. 4.27e+1. What is the difference between the highest and the lowest Imports (in Local Currency Unit) in Nepal?
Your response must be concise. 3.35e+09. 